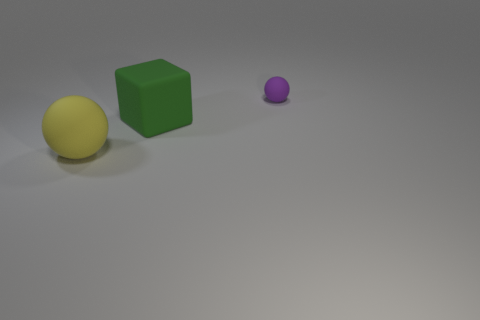Add 3 small rubber objects. How many objects exist? 6 Subtract all balls. How many objects are left? 1 Subtract all yellow matte spheres. Subtract all tiny purple matte things. How many objects are left? 1 Add 2 small matte balls. How many small matte balls are left? 3 Add 3 large green cubes. How many large green cubes exist? 4 Subtract 0 brown cylinders. How many objects are left? 3 